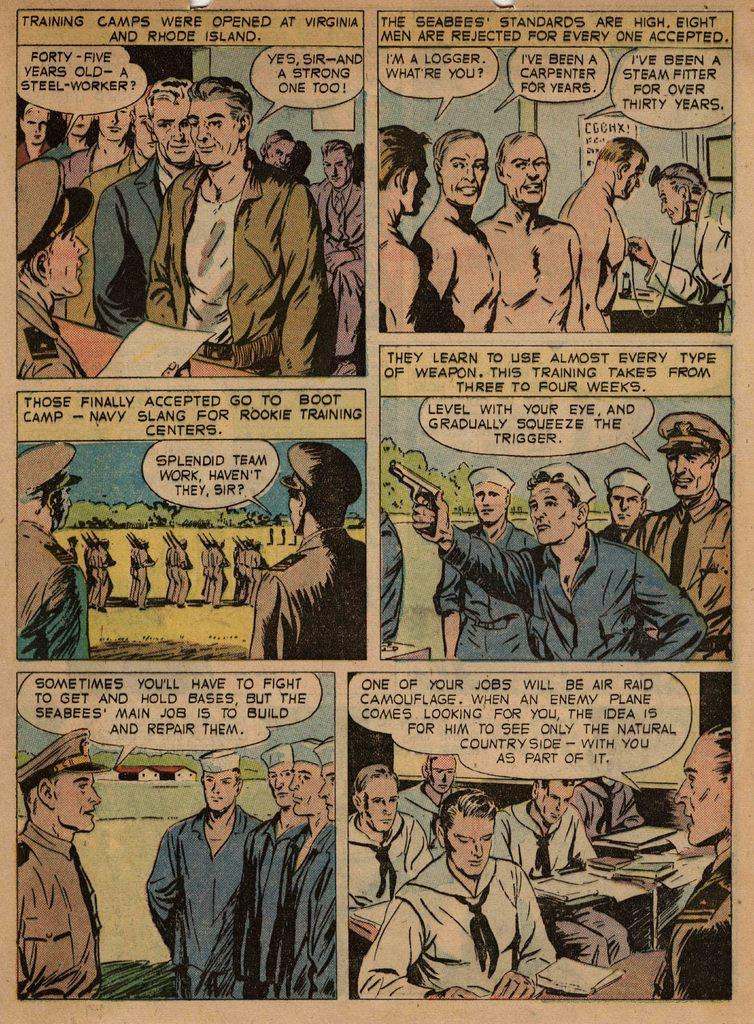Provide a one-sentence caption for the provided image. A color comic detailing when Training camps were opened at Virginia and Rhode Island. 